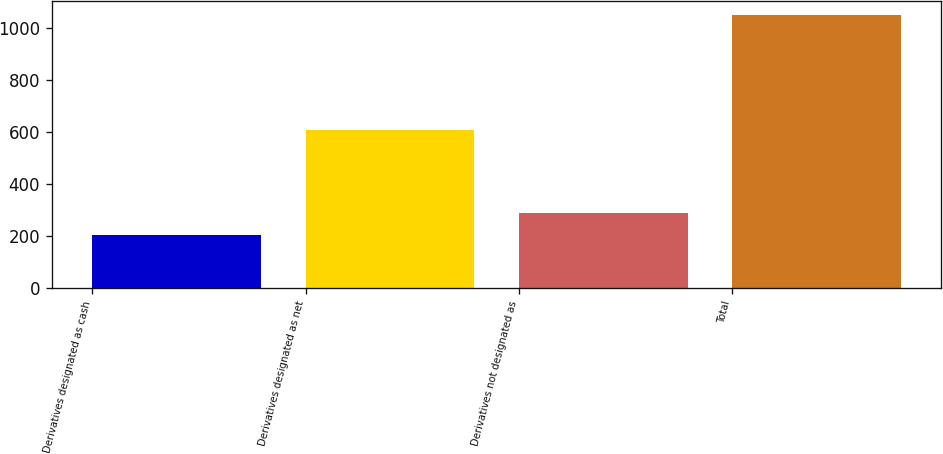<chart> <loc_0><loc_0><loc_500><loc_500><bar_chart><fcel>Derivatives designated as cash<fcel>Derivatives designated as net<fcel>Derivatives not designated as<fcel>Total<nl><fcel>203<fcel>608<fcel>287.8<fcel>1051<nl></chart> 